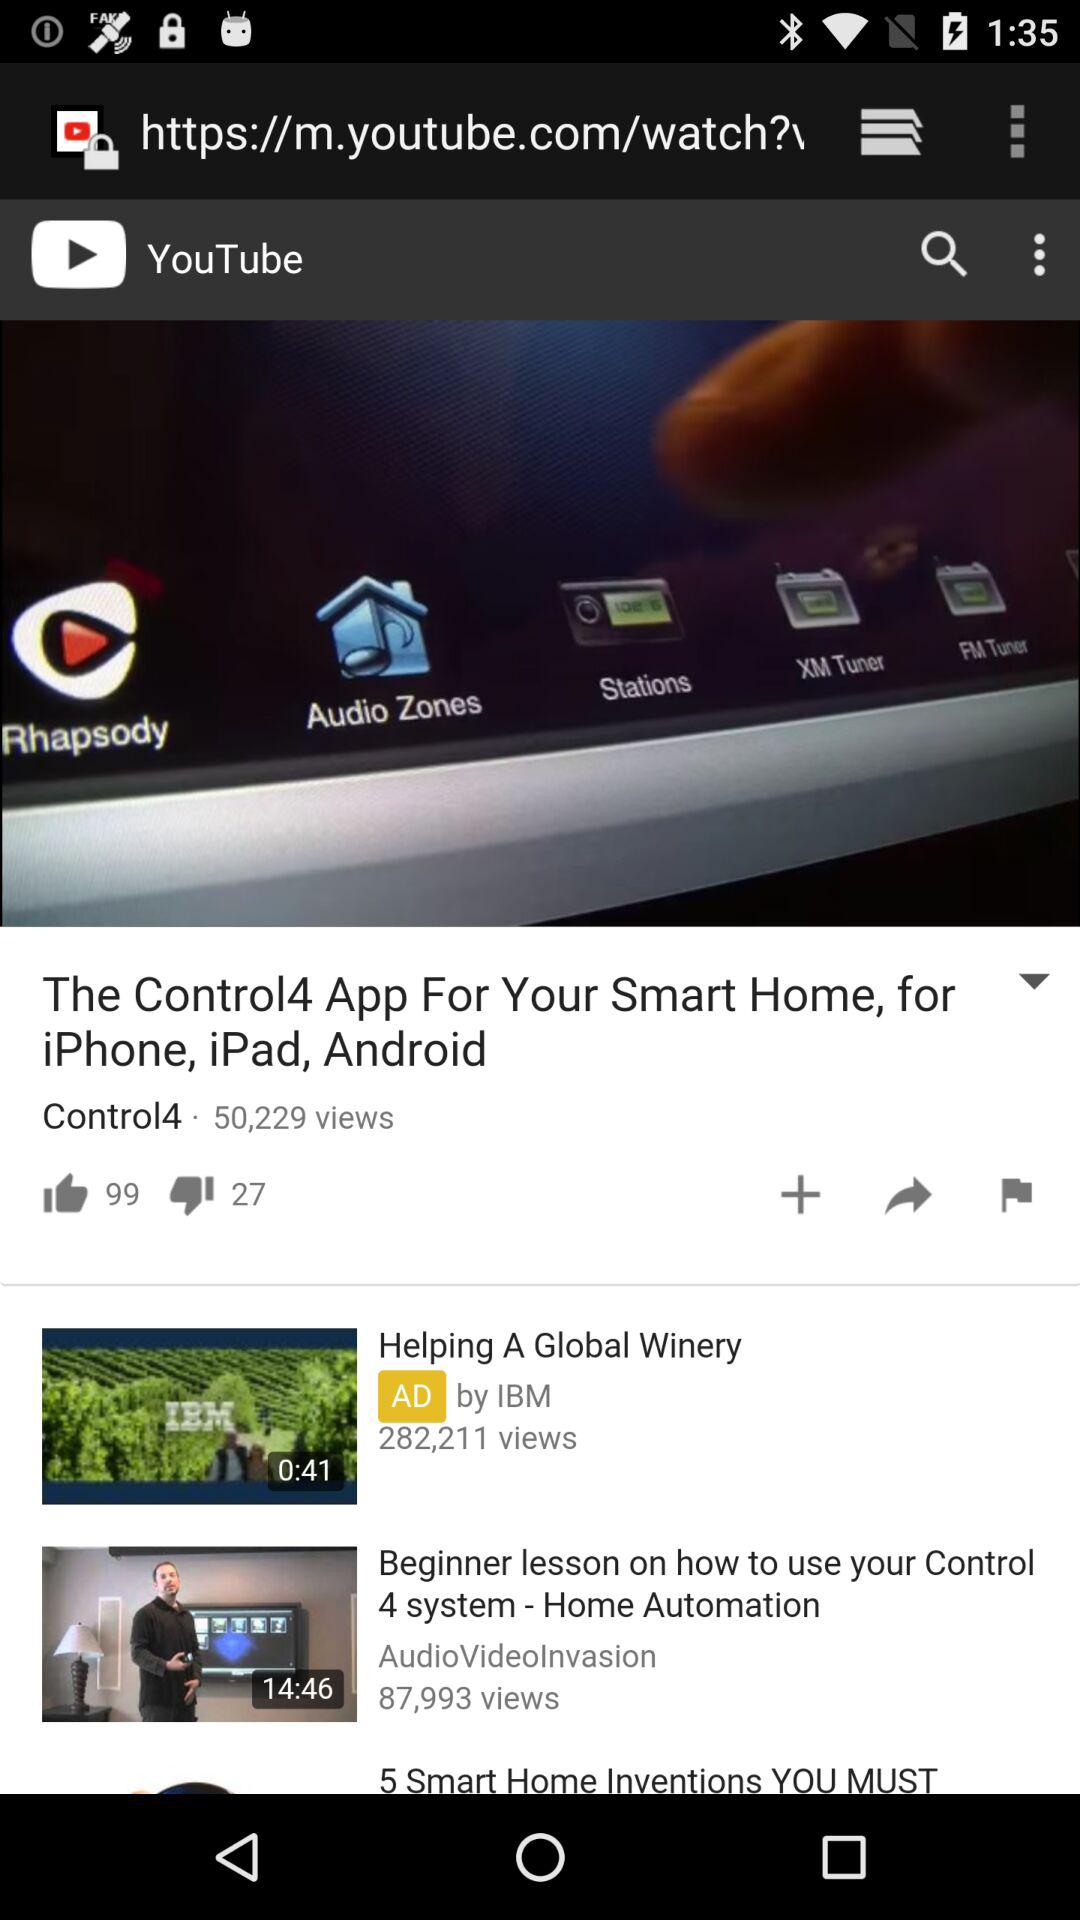How many views are there of the "The Control4 App For Your Smart Home, for iPhone, iPad, Android" video? There are 50,229 views. 